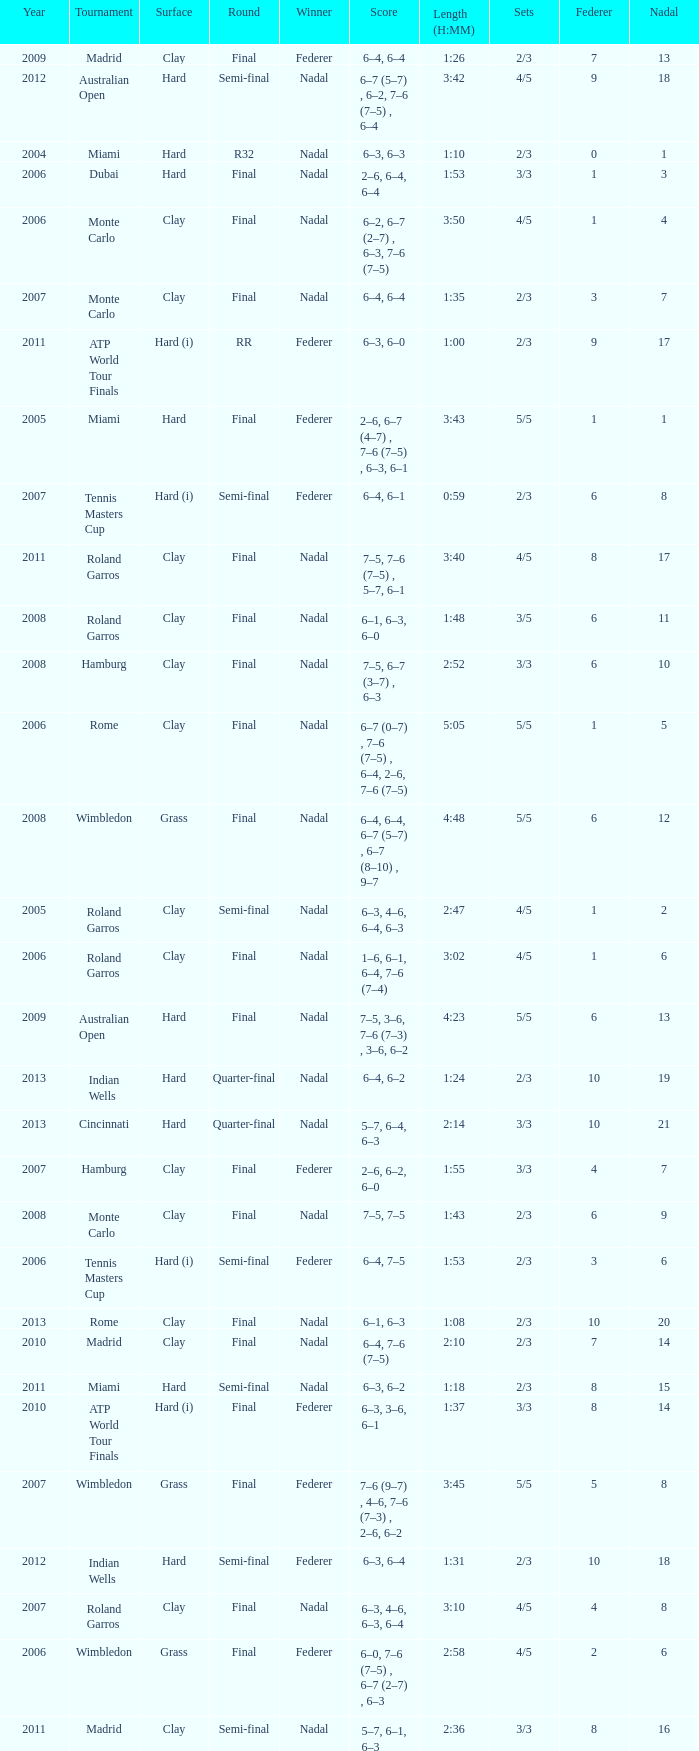What were the sets when Federer had 6 and a nadal of 13? 5/5. 